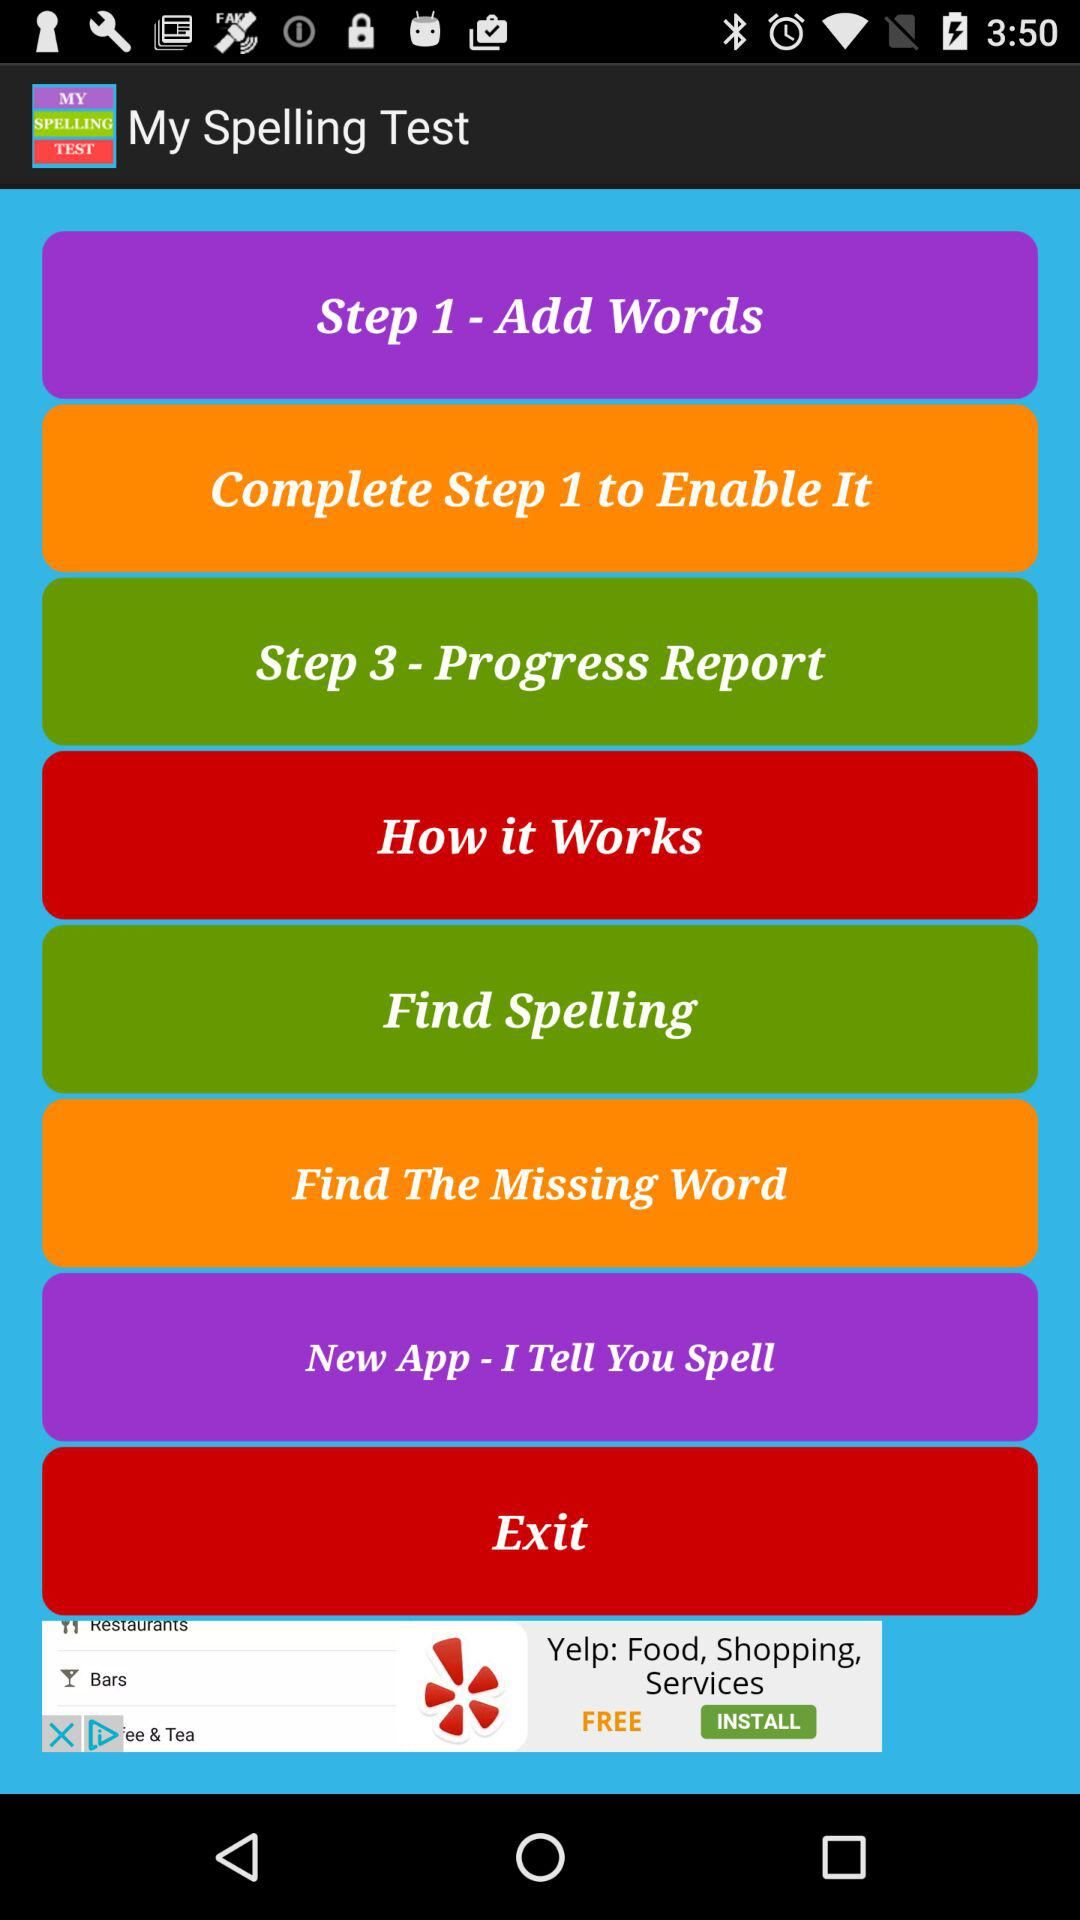What is step 1? Step 1 is "Add Words". 